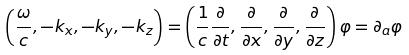Convert formula to latex. <formula><loc_0><loc_0><loc_500><loc_500>\left ( \frac { \omega } { c } , - k _ { x } , - k _ { y } , - k _ { z } \right ) = \left ( \frac { 1 } { c } \frac { \partial } { \partial t } , \frac { \partial } { \partial x } , \frac { \partial } { \partial y } , \frac { \partial } { \partial z } \right ) \varphi = \partial _ { a } \varphi</formula> 